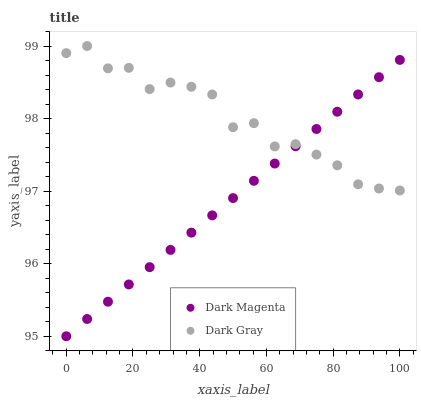Does Dark Magenta have the minimum area under the curve?
Answer yes or no. Yes. Does Dark Gray have the maximum area under the curve?
Answer yes or no. Yes. Does Dark Magenta have the maximum area under the curve?
Answer yes or no. No. Is Dark Magenta the smoothest?
Answer yes or no. Yes. Is Dark Gray the roughest?
Answer yes or no. Yes. Is Dark Magenta the roughest?
Answer yes or no. No. Does Dark Magenta have the lowest value?
Answer yes or no. Yes. Does Dark Gray have the highest value?
Answer yes or no. Yes. Does Dark Magenta have the highest value?
Answer yes or no. No. Does Dark Magenta intersect Dark Gray?
Answer yes or no. Yes. Is Dark Magenta less than Dark Gray?
Answer yes or no. No. Is Dark Magenta greater than Dark Gray?
Answer yes or no. No. 